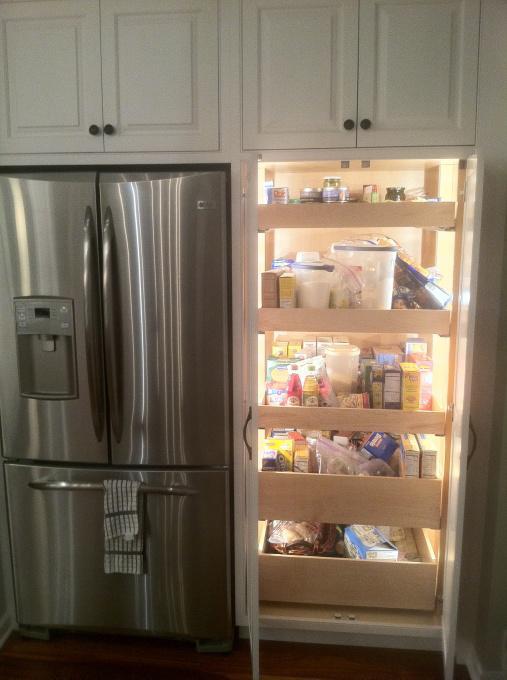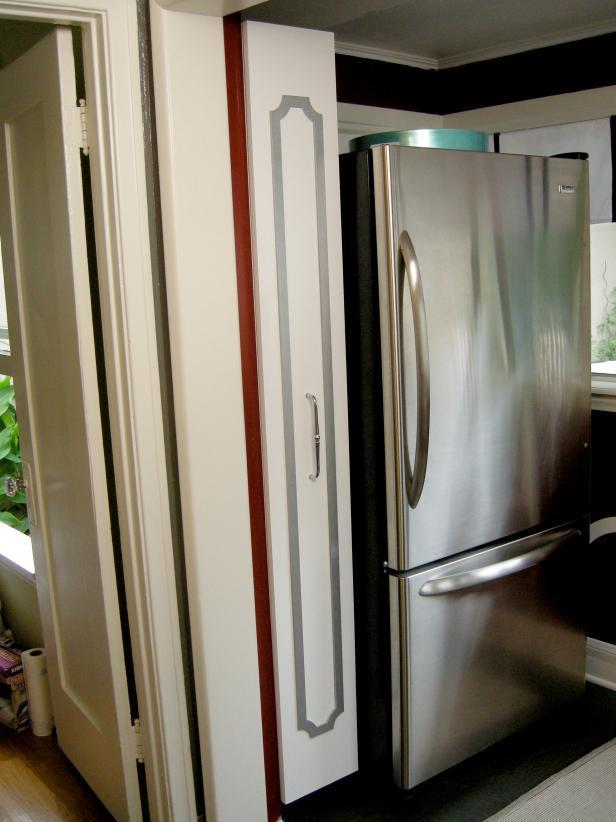The first image is the image on the left, the second image is the image on the right. Assess this claim about the two images: "At least one set of doors is closed in the image on the right.". Correct or not? Answer yes or no. Yes. The first image is the image on the left, the second image is the image on the right. Analyze the images presented: Is the assertion "Left image shows a vertical storage pantry that pulls out, and the image does not include a refrigerator." valid? Answer yes or no. No. 